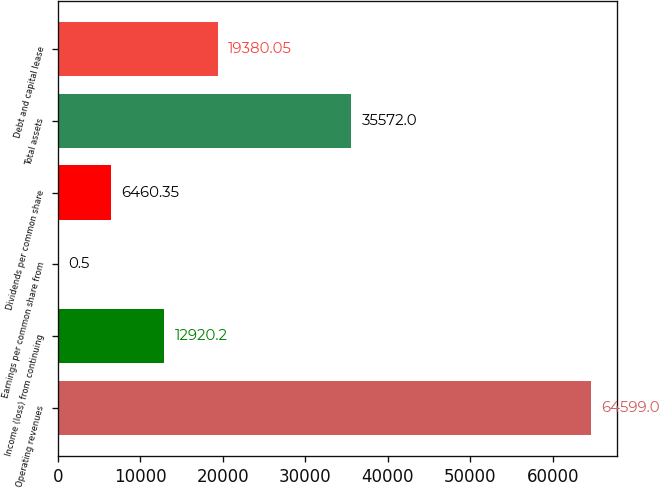<chart> <loc_0><loc_0><loc_500><loc_500><bar_chart><fcel>Operating revenues<fcel>Income (loss) from continuing<fcel>Earnings per common share from<fcel>Dividends per common share<fcel>Total assets<fcel>Debt and capital lease<nl><fcel>64599<fcel>12920.2<fcel>0.5<fcel>6460.35<fcel>35572<fcel>19380<nl></chart> 